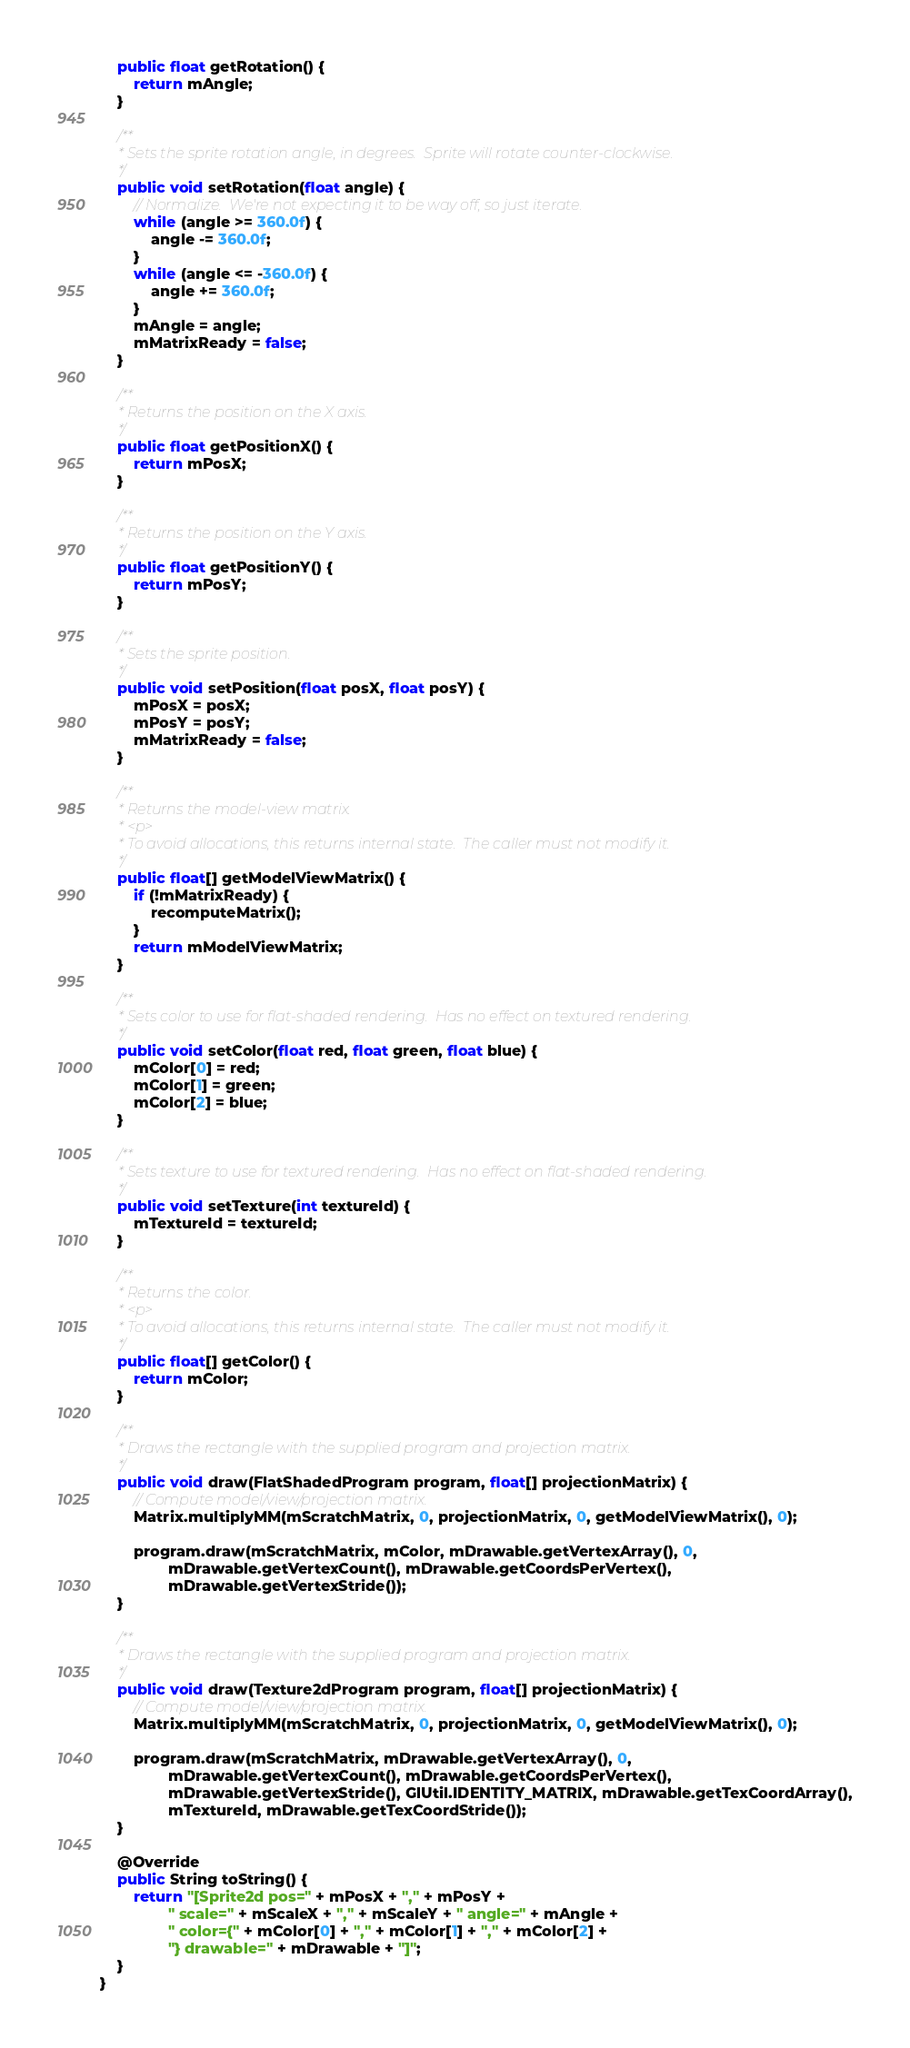<code> <loc_0><loc_0><loc_500><loc_500><_Java_>    public float getRotation() {
        return mAngle;
    }

    /**
     * Sets the sprite rotation angle, in degrees.  Sprite will rotate counter-clockwise.
     */
    public void setRotation(float angle) {
        // Normalize.  We're not expecting it to be way off, so just iterate.
        while (angle >= 360.0f) {
            angle -= 360.0f;
        }
        while (angle <= -360.0f) {
            angle += 360.0f;
        }
        mAngle = angle;
        mMatrixReady = false;
    }

    /**
     * Returns the position on the X axis.
     */
    public float getPositionX() {
        return mPosX;
    }

    /**
     * Returns the position on the Y axis.
     */
    public float getPositionY() {
        return mPosY;
    }

    /**
     * Sets the sprite position.
     */
    public void setPosition(float posX, float posY) {
        mPosX = posX;
        mPosY = posY;
        mMatrixReady = false;
    }

    /**
     * Returns the model-view matrix.
     * <p>
     * To avoid allocations, this returns internal state.  The caller must not modify it.
     */
    public float[] getModelViewMatrix() {
        if (!mMatrixReady) {
            recomputeMatrix();
        }
        return mModelViewMatrix;
    }

    /**
     * Sets color to use for flat-shaded rendering.  Has no effect on textured rendering.
     */
    public void setColor(float red, float green, float blue) {
        mColor[0] = red;
        mColor[1] = green;
        mColor[2] = blue;
    }

    /**
     * Sets texture to use for textured rendering.  Has no effect on flat-shaded rendering.
     */
    public void setTexture(int textureId) {
        mTextureId = textureId;
    }

    /**
     * Returns the color.
     * <p>
     * To avoid allocations, this returns internal state.  The caller must not modify it.
     */
    public float[] getColor() {
        return mColor;
    }

    /**
     * Draws the rectangle with the supplied program and projection matrix.
     */
    public void draw(FlatShadedProgram program, float[] projectionMatrix) {
        // Compute model/view/projection matrix.
        Matrix.multiplyMM(mScratchMatrix, 0, projectionMatrix, 0, getModelViewMatrix(), 0);

        program.draw(mScratchMatrix, mColor, mDrawable.getVertexArray(), 0,
                mDrawable.getVertexCount(), mDrawable.getCoordsPerVertex(),
                mDrawable.getVertexStride());
    }

    /**
     * Draws the rectangle with the supplied program and projection matrix.
     */
    public void draw(Texture2dProgram program, float[] projectionMatrix) {
        // Compute model/view/projection matrix.
        Matrix.multiplyMM(mScratchMatrix, 0, projectionMatrix, 0, getModelViewMatrix(), 0);

        program.draw(mScratchMatrix, mDrawable.getVertexArray(), 0,
                mDrawable.getVertexCount(), mDrawable.getCoordsPerVertex(),
                mDrawable.getVertexStride(), GlUtil.IDENTITY_MATRIX, mDrawable.getTexCoordArray(),
                mTextureId, mDrawable.getTexCoordStride());
    }

    @Override
    public String toString() {
        return "[Sprite2d pos=" + mPosX + "," + mPosY +
                " scale=" + mScaleX + "," + mScaleY + " angle=" + mAngle +
                " color={" + mColor[0] + "," + mColor[1] + "," + mColor[2] +
                "} drawable=" + mDrawable + "]";
    }
}
</code> 